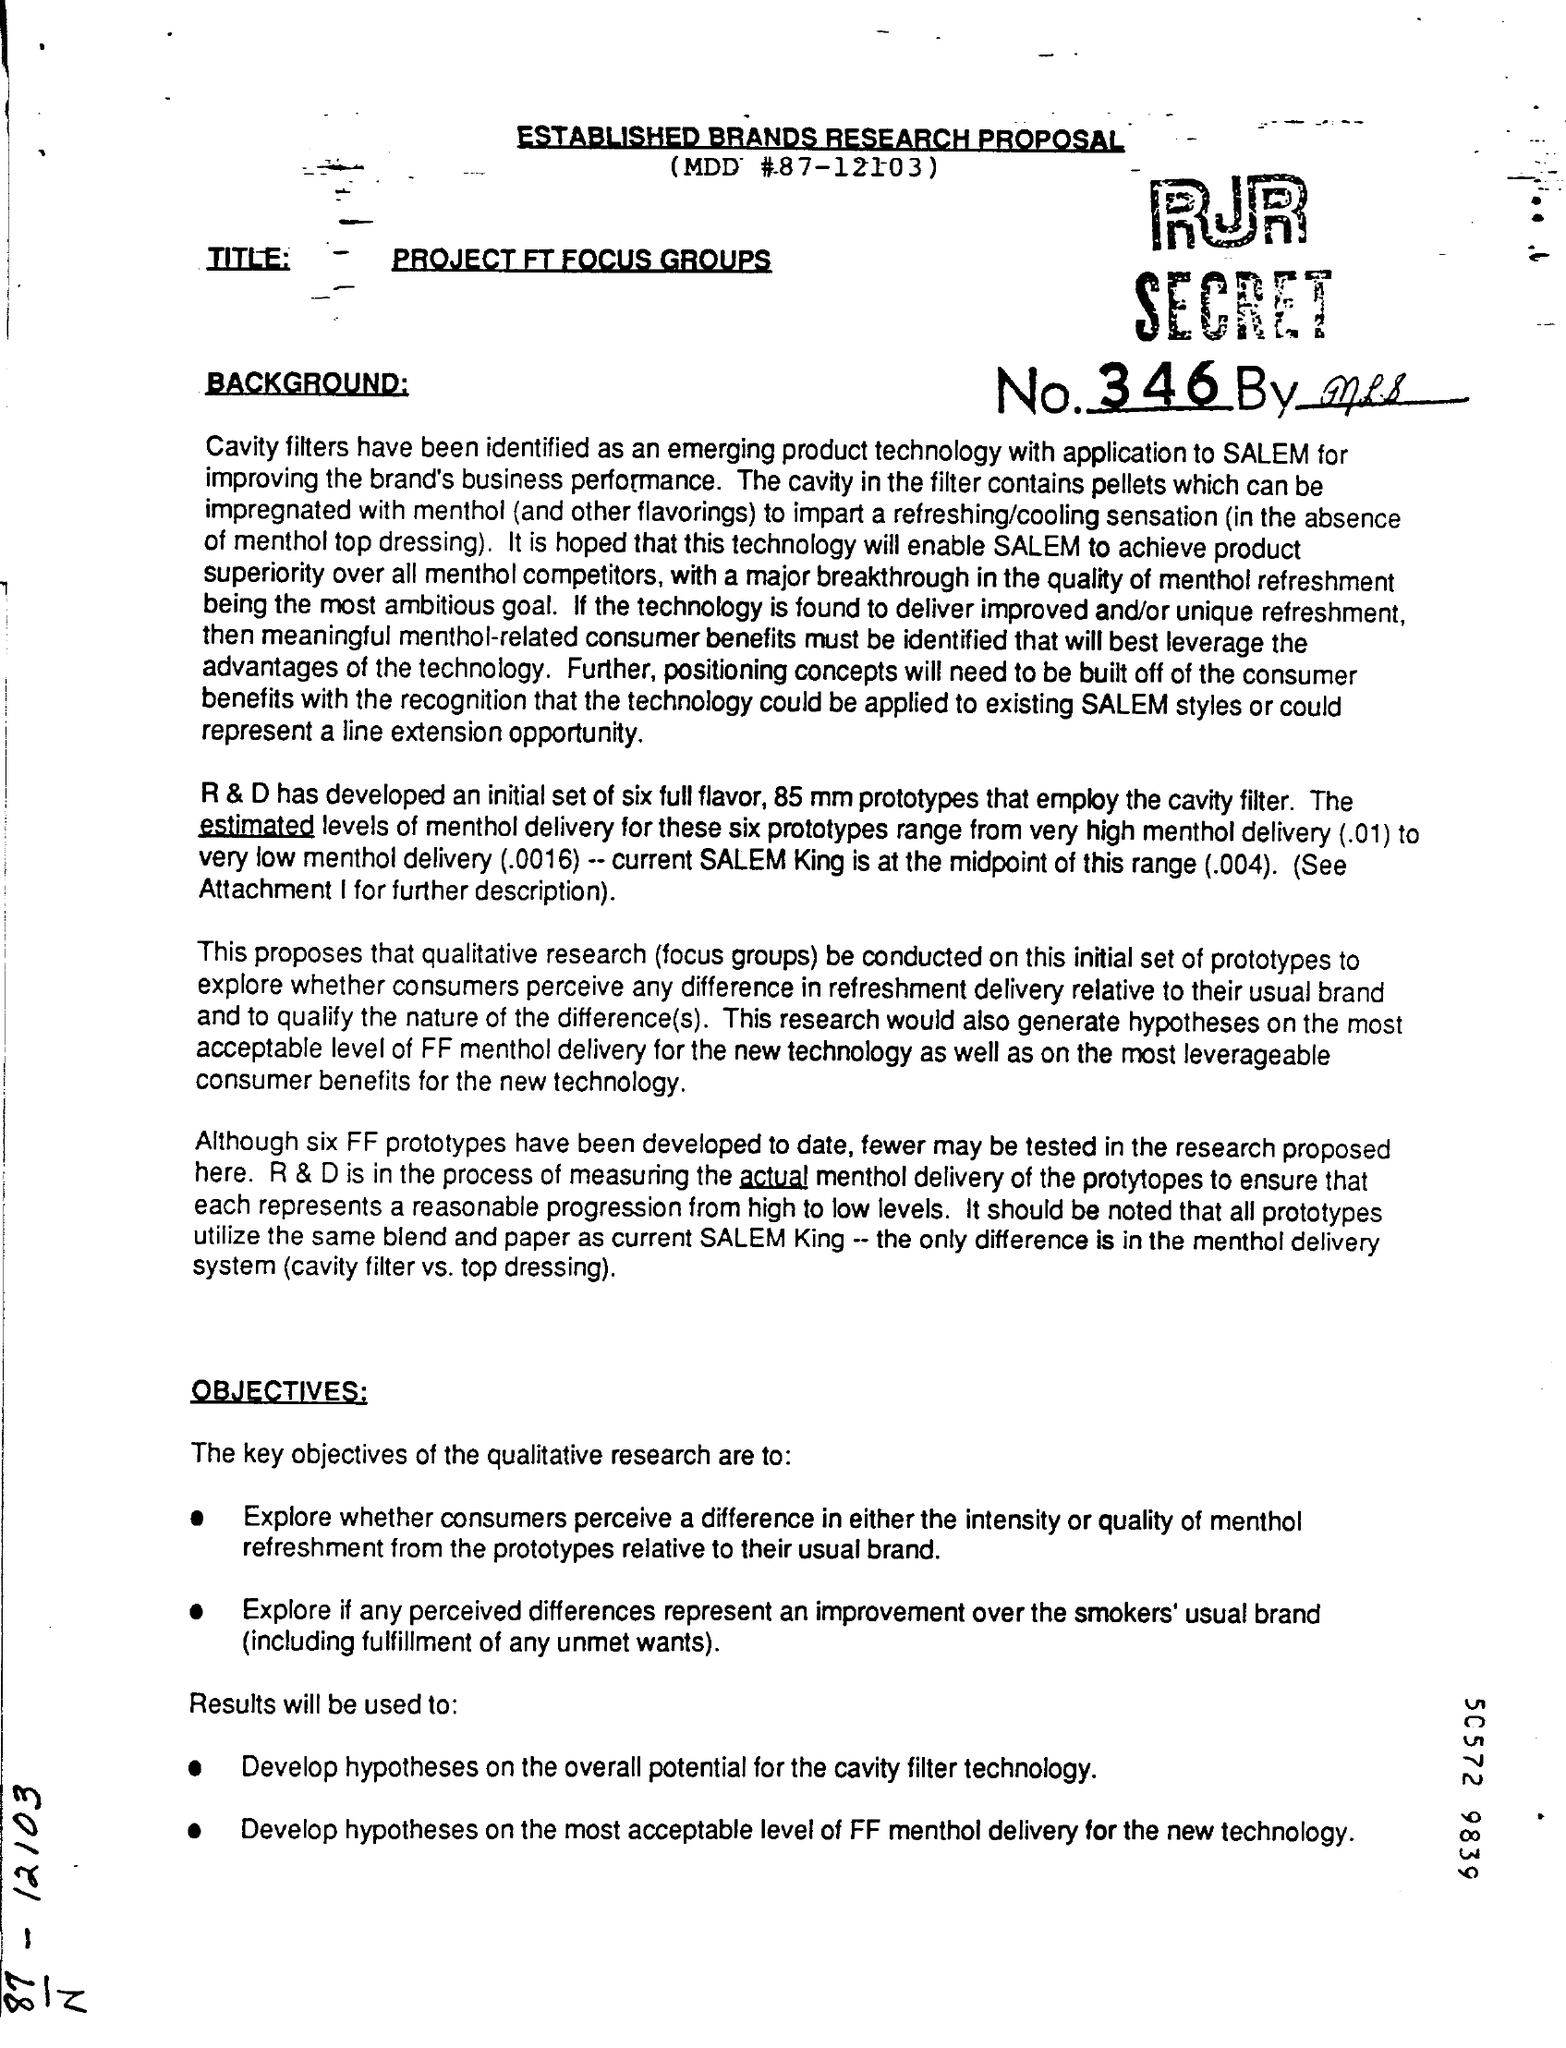What is the MDD #?
Offer a very short reply. 87-12103. 